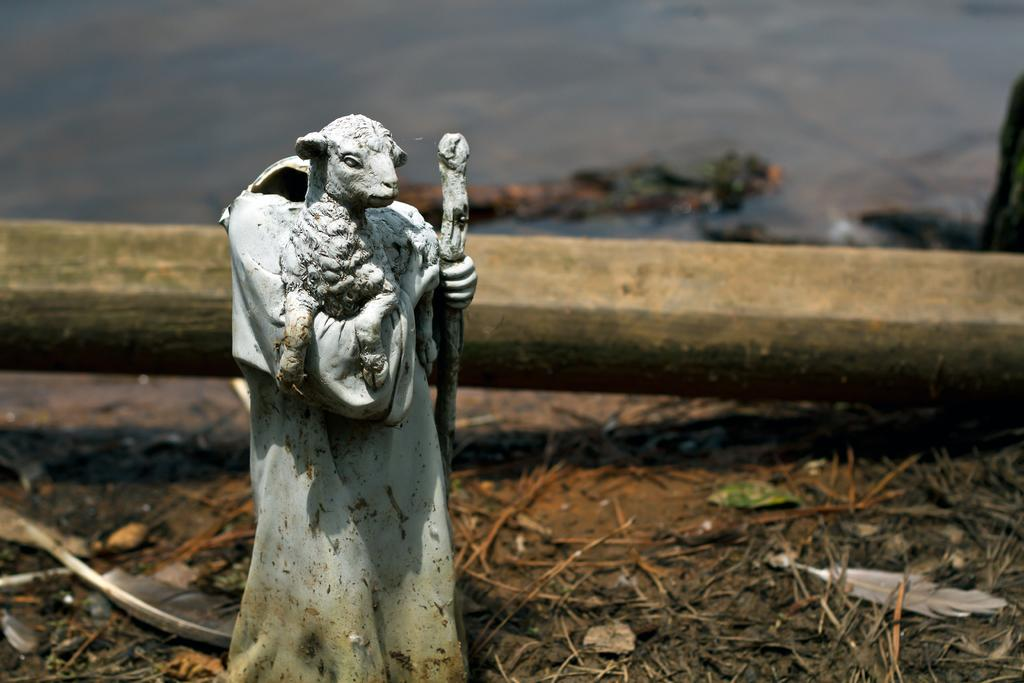What is the main subject in the image? There is a statue in the image. What else can be seen in the image besides the statue? Water is visible in the image. How many bears are holding a thread and a pin in the image? There are no bears, thread, or pins present in the image. 